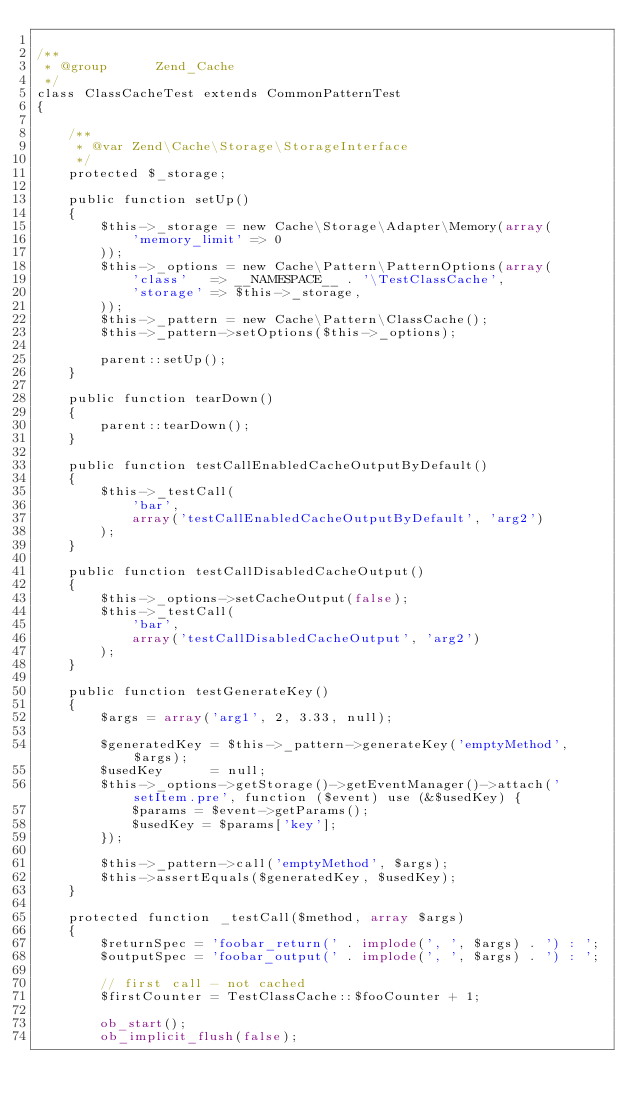Convert code to text. <code><loc_0><loc_0><loc_500><loc_500><_PHP_>
/**
 * @group      Zend_Cache
 */
class ClassCacheTest extends CommonPatternTest
{

    /**
     * @var Zend\Cache\Storage\StorageInterface
     */
    protected $_storage;

    public function setUp()
    {
        $this->_storage = new Cache\Storage\Adapter\Memory(array(
            'memory_limit' => 0
        ));
        $this->_options = new Cache\Pattern\PatternOptions(array(
            'class'   => __NAMESPACE__ . '\TestClassCache',
            'storage' => $this->_storage,
        ));
        $this->_pattern = new Cache\Pattern\ClassCache();
        $this->_pattern->setOptions($this->_options);

        parent::setUp();
    }

    public function tearDown()
    {
        parent::tearDown();
    }

    public function testCallEnabledCacheOutputByDefault()
    {
        $this->_testCall(
            'bar',
            array('testCallEnabledCacheOutputByDefault', 'arg2')
        );
    }

    public function testCallDisabledCacheOutput()
    {
        $this->_options->setCacheOutput(false);
        $this->_testCall(
            'bar',
            array('testCallDisabledCacheOutput', 'arg2')
        );
    }

    public function testGenerateKey()
    {
        $args = array('arg1', 2, 3.33, null);

        $generatedKey = $this->_pattern->generateKey('emptyMethod', $args);
        $usedKey      = null;
        $this->_options->getStorage()->getEventManager()->attach('setItem.pre', function ($event) use (&$usedKey) {
            $params = $event->getParams();
            $usedKey = $params['key'];
        });

        $this->_pattern->call('emptyMethod', $args);
        $this->assertEquals($generatedKey, $usedKey);
    }

    protected function _testCall($method, array $args)
    {
        $returnSpec = 'foobar_return(' . implode(', ', $args) . ') : ';
        $outputSpec = 'foobar_output(' . implode(', ', $args) . ') : ';

        // first call - not cached
        $firstCounter = TestClassCache::$fooCounter + 1;

        ob_start();
        ob_implicit_flush(false);</code> 